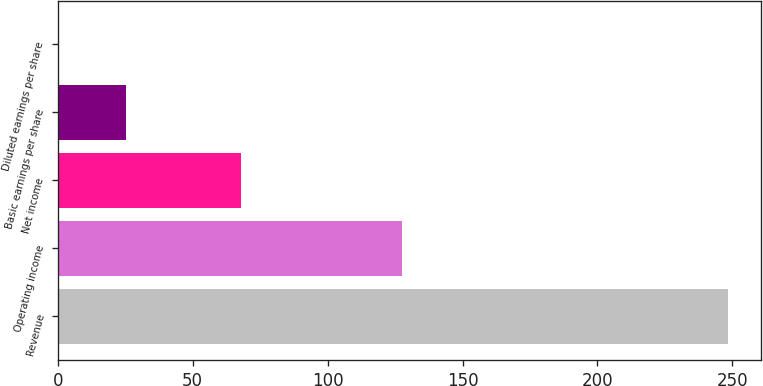Convert chart. <chart><loc_0><loc_0><loc_500><loc_500><bar_chart><fcel>Revenue<fcel>Operating income<fcel>Net income<fcel>Basic earnings per share<fcel>Diluted earnings per share<nl><fcel>248.3<fcel>127.4<fcel>67.8<fcel>25.22<fcel>0.43<nl></chart> 